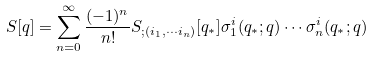Convert formula to latex. <formula><loc_0><loc_0><loc_500><loc_500>S [ q ] = \sum _ { n = 0 } ^ { \infty } \frac { ( - 1 ) ^ { n } } { n ! } S _ { ; ( i _ { 1 } , \cdots i _ { n } ) } [ q _ { \ast } ] \sigma ^ { i } _ { 1 } ( q _ { \ast } ; q ) \cdots \sigma ^ { i } _ { n } ( q _ { \ast } ; q )</formula> 